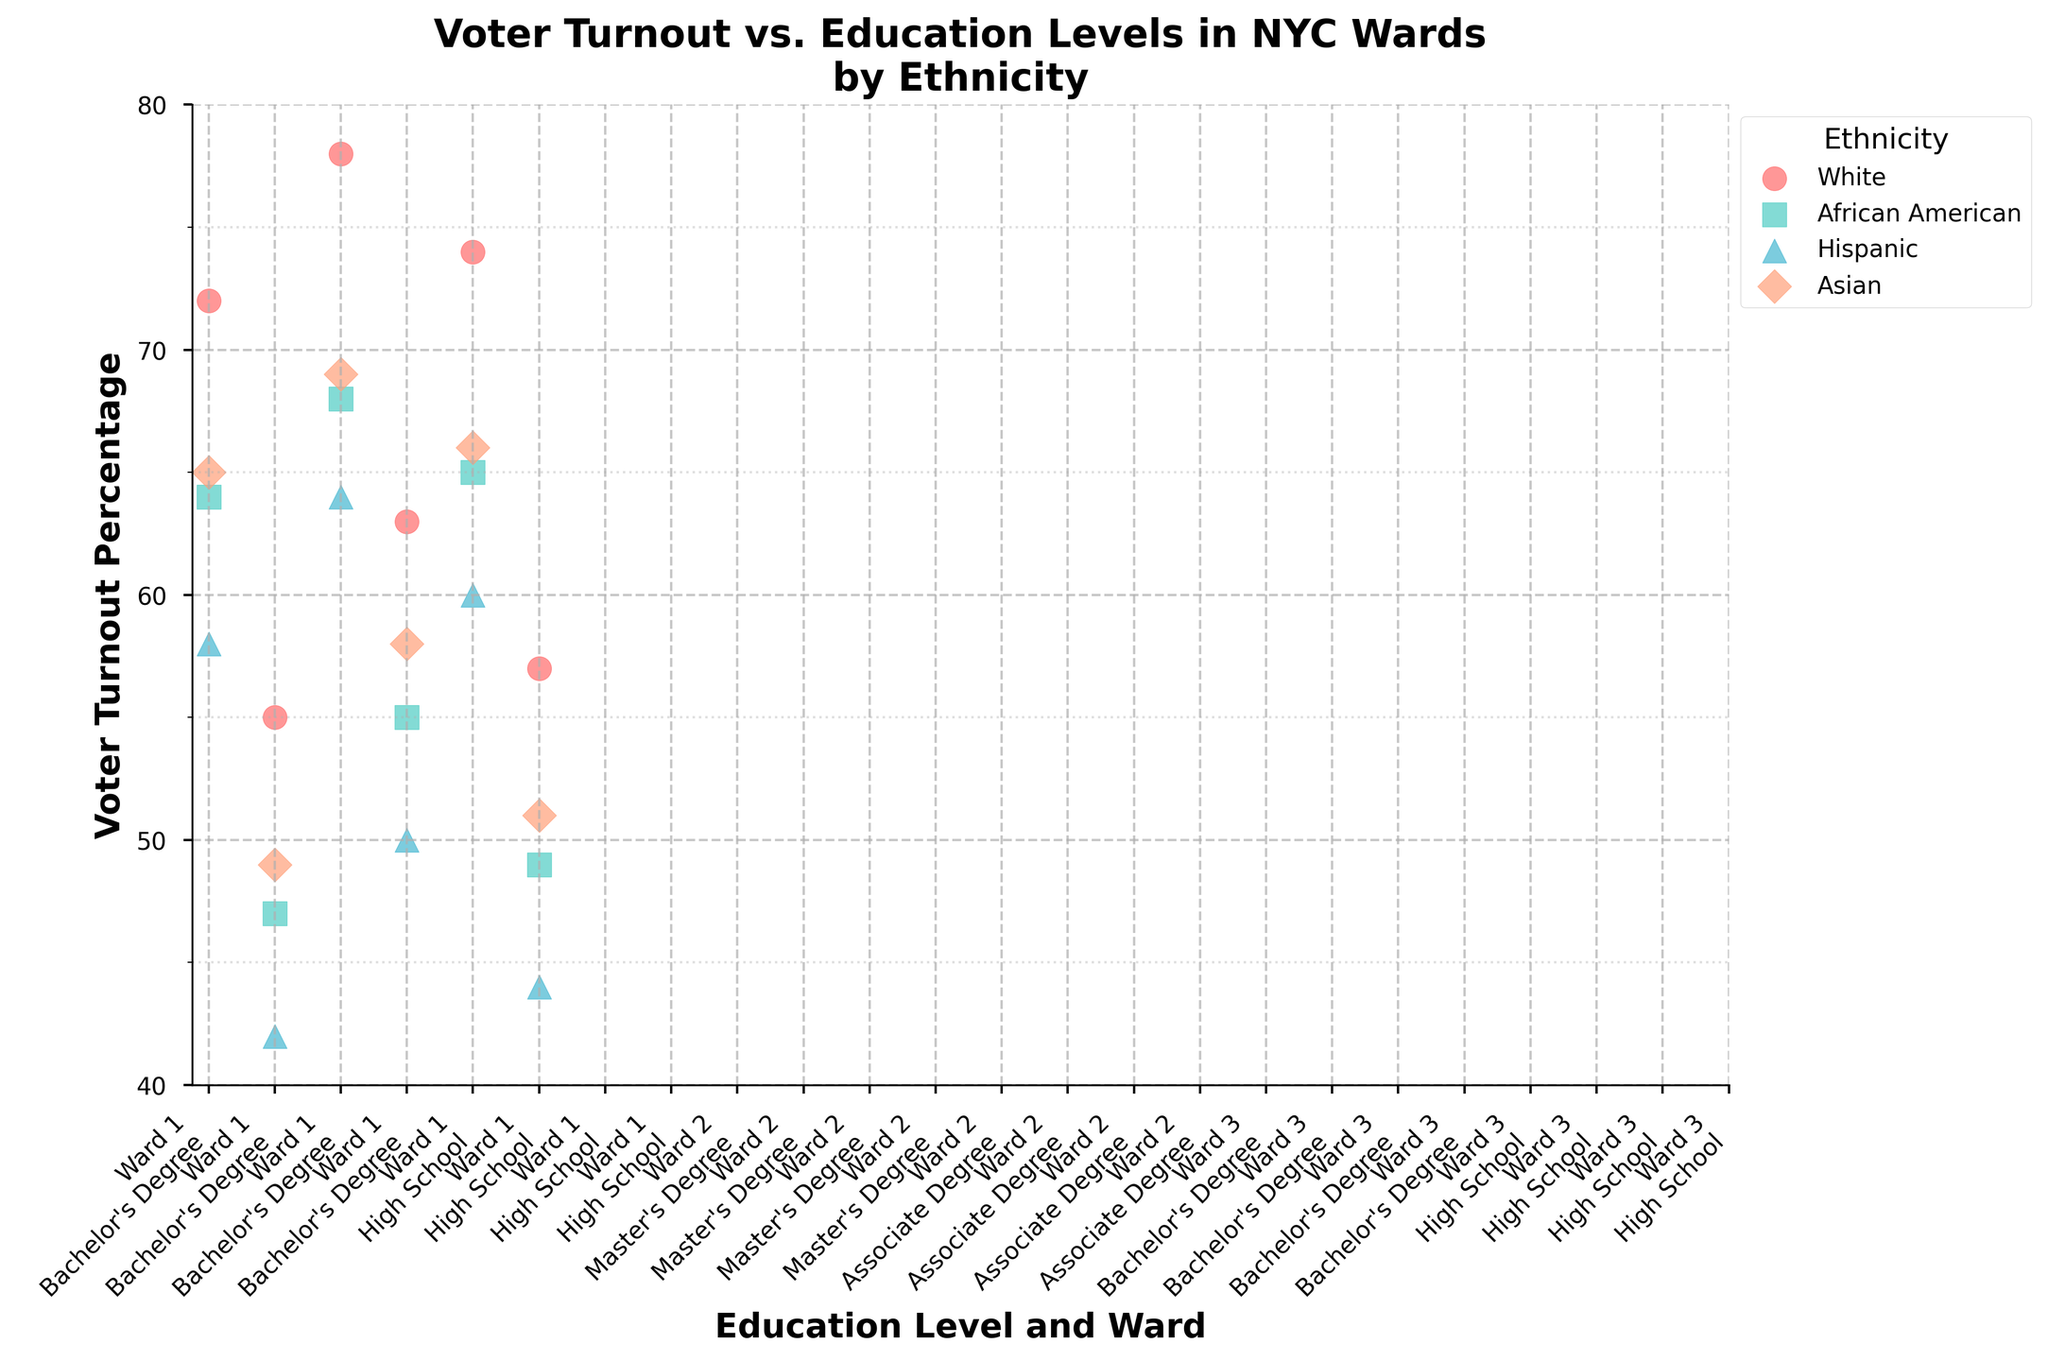What is the title of the plot? Look at the top of the plot where the title is usually placed. It reads "Voter Turnout vs. Education Levels in NYC Wards by Ethnicity".
Answer: Voter Turnout vs. Education Levels in NYC Wards by Ethnicity What is the voter turnout percentage for African Americans with a Bachelor’s Degree in Ward 1? Find the data points related to African Americans, located by the unique markers and color. The voter turnout percentage for African Americans with a Bachelor's Degree in Ward 1 is labeled as 64.
Answer: 64% How many ethnicities are represented in the plot? By looking at the legend on the right side of the plot, which assigns different colors and markers to each ethnicity, you can see there are four ethnicities: White, African American, Hispanic, and Asian.
Answer: 4 Between which two ethnic groups is the smallest difference in voter turnout for individuals with High School education in Ward 1? Look at the voter turnout percentages for all ethnic groups with High School education in Ward 1. The smallest difference can be calculated by comparing all possible pairs. White (55%) and Asian (49%) have a difference of 6 percentage points, which is the smallest.
Answer: Asian and White What is the range of voter turnout percentages for Ward 1? Determine the minimum and maximum voter turnout percentages in Ward 1 across all ethnicities and education levels. The range is calculated by subtracting the minimum value from the maximum value. The values are 42% to 72%, making the range 72 - 42 = 30 percentage points.
Answer: 30 percentage points Which ward has the highest voter turnout percentage for individuals with a Master's Degree? Look at the data points related to people with Master's Degrees in each ward. The highest voter turnout percentage is in Ward 2 at 78% for White individuals.
Answer: Ward 2 Compare the voter turnout percentages for Hispanics with Bachelor's Degrees in Ward 1 and Ward 3. Look at the data points related to Hispanics with Bachelor's Degrees in both Ward 1 and Ward 3. In Ward 1, it is 58%, and in Ward 3, it is 60%.
Answer: 60% in Ward 3, 58% in Ward 1 What is the average voter turnout percentage for Asians with different education levels in Ward 1? Identify every data point for Asians in Ward 1 and calculate the average of their voter turnout percentages. The values are 65%, 49%, and 42%. The average is (65 + 65 + 49) / 3 = 59.67%.
Answer: 60% (rounded) For which ethnic group does a higher education level consistently result in higher voter turnout percentages across all wards? Compare voter turnout percentages for different education levels within each ethnic group across all wards. For Asians, higher education levels consistently result in higher voter turnout percentages: Master's -> 69%, Bachelor's -> 65%, Associate's -> 58%, High School -> 49%.
Answer: Asians 